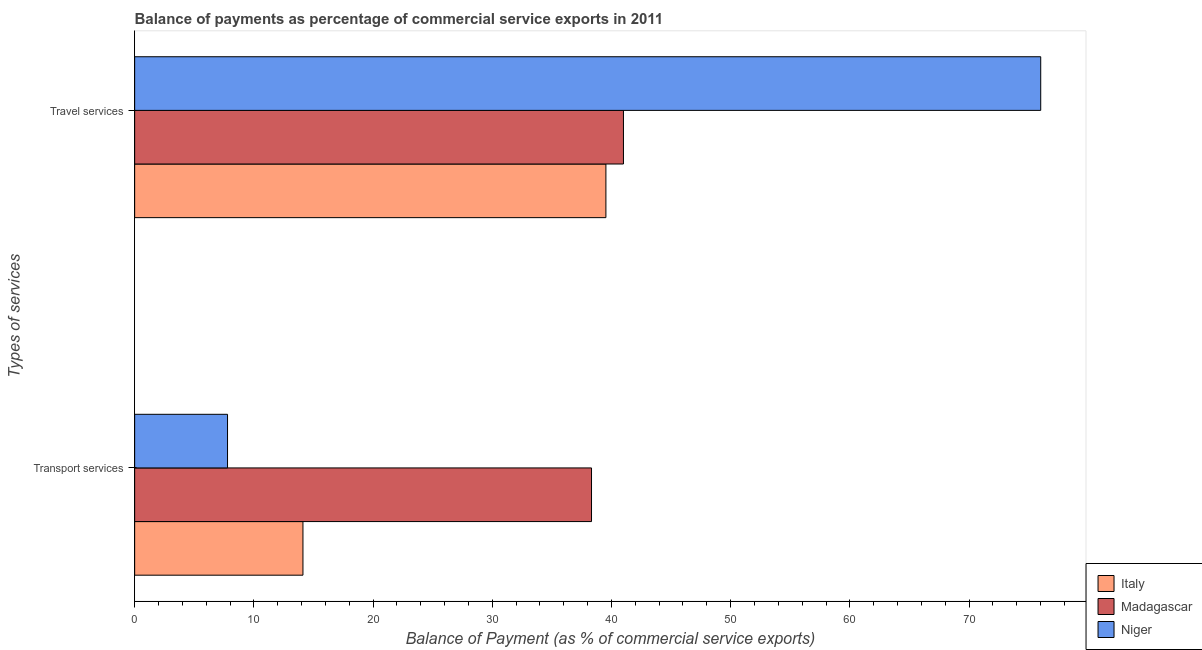How many bars are there on the 1st tick from the bottom?
Your response must be concise. 3. What is the label of the 1st group of bars from the top?
Make the answer very short. Travel services. What is the balance of payments of transport services in Madagascar?
Your answer should be compact. 38.33. Across all countries, what is the maximum balance of payments of travel services?
Keep it short and to the point. 76.01. Across all countries, what is the minimum balance of payments of travel services?
Keep it short and to the point. 39.53. In which country was the balance of payments of transport services maximum?
Your response must be concise. Madagascar. What is the total balance of payments of travel services in the graph?
Your response must be concise. 156.55. What is the difference between the balance of payments of transport services in Italy and that in Madagascar?
Make the answer very short. -24.21. What is the difference between the balance of payments of transport services in Madagascar and the balance of payments of travel services in Niger?
Keep it short and to the point. -37.68. What is the average balance of payments of travel services per country?
Your answer should be compact. 52.18. What is the difference between the balance of payments of travel services and balance of payments of transport services in Niger?
Ensure brevity in your answer.  68.22. In how many countries, is the balance of payments of transport services greater than 48 %?
Make the answer very short. 0. What is the ratio of the balance of payments of travel services in Madagascar to that in Italy?
Offer a very short reply. 1.04. In how many countries, is the balance of payments of travel services greater than the average balance of payments of travel services taken over all countries?
Give a very brief answer. 1. What does the 1st bar from the top in Transport services represents?
Make the answer very short. Niger. What does the 1st bar from the bottom in Transport services represents?
Keep it short and to the point. Italy. What is the difference between two consecutive major ticks on the X-axis?
Offer a terse response. 10. Are the values on the major ticks of X-axis written in scientific E-notation?
Offer a terse response. No. Does the graph contain any zero values?
Provide a short and direct response. No. Where does the legend appear in the graph?
Give a very brief answer. Bottom right. How many legend labels are there?
Ensure brevity in your answer.  3. How are the legend labels stacked?
Ensure brevity in your answer.  Vertical. What is the title of the graph?
Your response must be concise. Balance of payments as percentage of commercial service exports in 2011. What is the label or title of the X-axis?
Your answer should be compact. Balance of Payment (as % of commercial service exports). What is the label or title of the Y-axis?
Give a very brief answer. Types of services. What is the Balance of Payment (as % of commercial service exports) in Italy in Transport services?
Offer a terse response. 14.12. What is the Balance of Payment (as % of commercial service exports) of Madagascar in Transport services?
Keep it short and to the point. 38.33. What is the Balance of Payment (as % of commercial service exports) in Niger in Transport services?
Provide a short and direct response. 7.79. What is the Balance of Payment (as % of commercial service exports) in Italy in Travel services?
Give a very brief answer. 39.53. What is the Balance of Payment (as % of commercial service exports) in Madagascar in Travel services?
Your response must be concise. 41.01. What is the Balance of Payment (as % of commercial service exports) of Niger in Travel services?
Make the answer very short. 76.01. Across all Types of services, what is the maximum Balance of Payment (as % of commercial service exports) of Italy?
Give a very brief answer. 39.53. Across all Types of services, what is the maximum Balance of Payment (as % of commercial service exports) of Madagascar?
Ensure brevity in your answer.  41.01. Across all Types of services, what is the maximum Balance of Payment (as % of commercial service exports) in Niger?
Provide a succinct answer. 76.01. Across all Types of services, what is the minimum Balance of Payment (as % of commercial service exports) of Italy?
Keep it short and to the point. 14.12. Across all Types of services, what is the minimum Balance of Payment (as % of commercial service exports) of Madagascar?
Provide a succinct answer. 38.33. Across all Types of services, what is the minimum Balance of Payment (as % of commercial service exports) in Niger?
Provide a short and direct response. 7.79. What is the total Balance of Payment (as % of commercial service exports) in Italy in the graph?
Your response must be concise. 53.65. What is the total Balance of Payment (as % of commercial service exports) of Madagascar in the graph?
Ensure brevity in your answer.  79.33. What is the total Balance of Payment (as % of commercial service exports) of Niger in the graph?
Make the answer very short. 83.8. What is the difference between the Balance of Payment (as % of commercial service exports) of Italy in Transport services and that in Travel services?
Offer a very short reply. -25.41. What is the difference between the Balance of Payment (as % of commercial service exports) of Madagascar in Transport services and that in Travel services?
Keep it short and to the point. -2.68. What is the difference between the Balance of Payment (as % of commercial service exports) of Niger in Transport services and that in Travel services?
Offer a very short reply. -68.22. What is the difference between the Balance of Payment (as % of commercial service exports) of Italy in Transport services and the Balance of Payment (as % of commercial service exports) of Madagascar in Travel services?
Provide a succinct answer. -26.89. What is the difference between the Balance of Payment (as % of commercial service exports) of Italy in Transport services and the Balance of Payment (as % of commercial service exports) of Niger in Travel services?
Your answer should be compact. -61.89. What is the difference between the Balance of Payment (as % of commercial service exports) in Madagascar in Transport services and the Balance of Payment (as % of commercial service exports) in Niger in Travel services?
Offer a terse response. -37.68. What is the average Balance of Payment (as % of commercial service exports) in Italy per Types of services?
Make the answer very short. 26.83. What is the average Balance of Payment (as % of commercial service exports) in Madagascar per Types of services?
Offer a very short reply. 39.67. What is the average Balance of Payment (as % of commercial service exports) in Niger per Types of services?
Your answer should be compact. 41.9. What is the difference between the Balance of Payment (as % of commercial service exports) of Italy and Balance of Payment (as % of commercial service exports) of Madagascar in Transport services?
Give a very brief answer. -24.21. What is the difference between the Balance of Payment (as % of commercial service exports) in Italy and Balance of Payment (as % of commercial service exports) in Niger in Transport services?
Provide a succinct answer. 6.33. What is the difference between the Balance of Payment (as % of commercial service exports) in Madagascar and Balance of Payment (as % of commercial service exports) in Niger in Transport services?
Keep it short and to the point. 30.54. What is the difference between the Balance of Payment (as % of commercial service exports) in Italy and Balance of Payment (as % of commercial service exports) in Madagascar in Travel services?
Offer a terse response. -1.47. What is the difference between the Balance of Payment (as % of commercial service exports) of Italy and Balance of Payment (as % of commercial service exports) of Niger in Travel services?
Make the answer very short. -36.48. What is the difference between the Balance of Payment (as % of commercial service exports) in Madagascar and Balance of Payment (as % of commercial service exports) in Niger in Travel services?
Keep it short and to the point. -35. What is the ratio of the Balance of Payment (as % of commercial service exports) in Italy in Transport services to that in Travel services?
Ensure brevity in your answer.  0.36. What is the ratio of the Balance of Payment (as % of commercial service exports) of Madagascar in Transport services to that in Travel services?
Provide a short and direct response. 0.93. What is the ratio of the Balance of Payment (as % of commercial service exports) of Niger in Transport services to that in Travel services?
Give a very brief answer. 0.1. What is the difference between the highest and the second highest Balance of Payment (as % of commercial service exports) of Italy?
Offer a terse response. 25.41. What is the difference between the highest and the second highest Balance of Payment (as % of commercial service exports) of Madagascar?
Ensure brevity in your answer.  2.68. What is the difference between the highest and the second highest Balance of Payment (as % of commercial service exports) of Niger?
Your response must be concise. 68.22. What is the difference between the highest and the lowest Balance of Payment (as % of commercial service exports) in Italy?
Ensure brevity in your answer.  25.41. What is the difference between the highest and the lowest Balance of Payment (as % of commercial service exports) of Madagascar?
Your answer should be very brief. 2.68. What is the difference between the highest and the lowest Balance of Payment (as % of commercial service exports) of Niger?
Give a very brief answer. 68.22. 